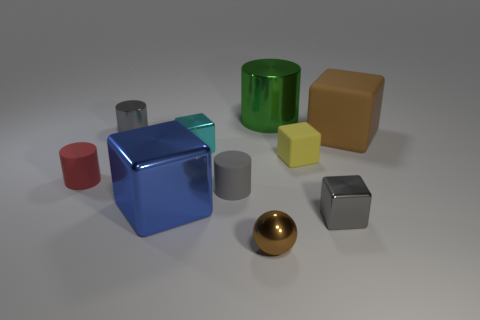There is a large object that is both behind the yellow rubber block and on the left side of the yellow matte thing; what is its material?
Make the answer very short. Metal. What is the size of the gray rubber cylinder?
Keep it short and to the point. Small. What color is the other big matte thing that is the same shape as the blue thing?
Your answer should be compact. Brown. Is there anything else that has the same color as the small metallic cylinder?
Make the answer very short. Yes. Does the gray shiny thing that is behind the brown block have the same size as the brown thing that is on the right side of the green shiny cylinder?
Offer a very short reply. No. Are there an equal number of matte blocks that are to the right of the small yellow cube and red matte things in front of the large rubber thing?
Provide a short and direct response. Yes. Do the green metallic object and the rubber object on the left side of the gray matte cylinder have the same size?
Keep it short and to the point. No. Is there a brown shiny thing behind the tiny metal cube in front of the red cylinder?
Your answer should be very brief. No. Are there any big cyan things of the same shape as the large brown thing?
Provide a succinct answer. No. There is a gray metal thing that is in front of the gray cylinder behind the tiny yellow object; what number of gray rubber cylinders are behind it?
Provide a succinct answer. 1. 